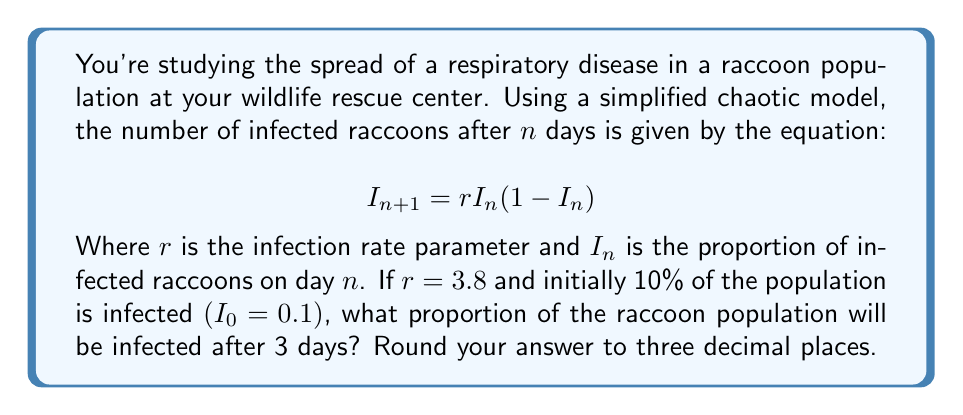Can you answer this question? To solve this problem, we need to iterate the given equation for 3 days:

1. Start with $I_0 = 0.1$ and $r = 3.8$

2. For day 1:
   $I_1 = 3.8 \cdot 0.1 \cdot (1-0.1)$
   $I_1 = 3.8 \cdot 0.1 \cdot 0.9 = 0.342$

3. For day 2:
   $I_2 = 3.8 \cdot 0.342 \cdot (1-0.342)$
   $I_2 = 3.8 \cdot 0.342 \cdot 0.658 = 0.855876$

4. For day 3:
   $I_3 = 3.8 \cdot 0.855876 \cdot (1-0.855876)$
   $I_3 = 3.8 \cdot 0.855876 \cdot 0.144124 = 0.468895$

5. Rounding to three decimal places:
   $I_3 \approx 0.469$

Therefore, after 3 days, approximately 46.9% of the raccoon population will be infected.
Answer: 0.469 